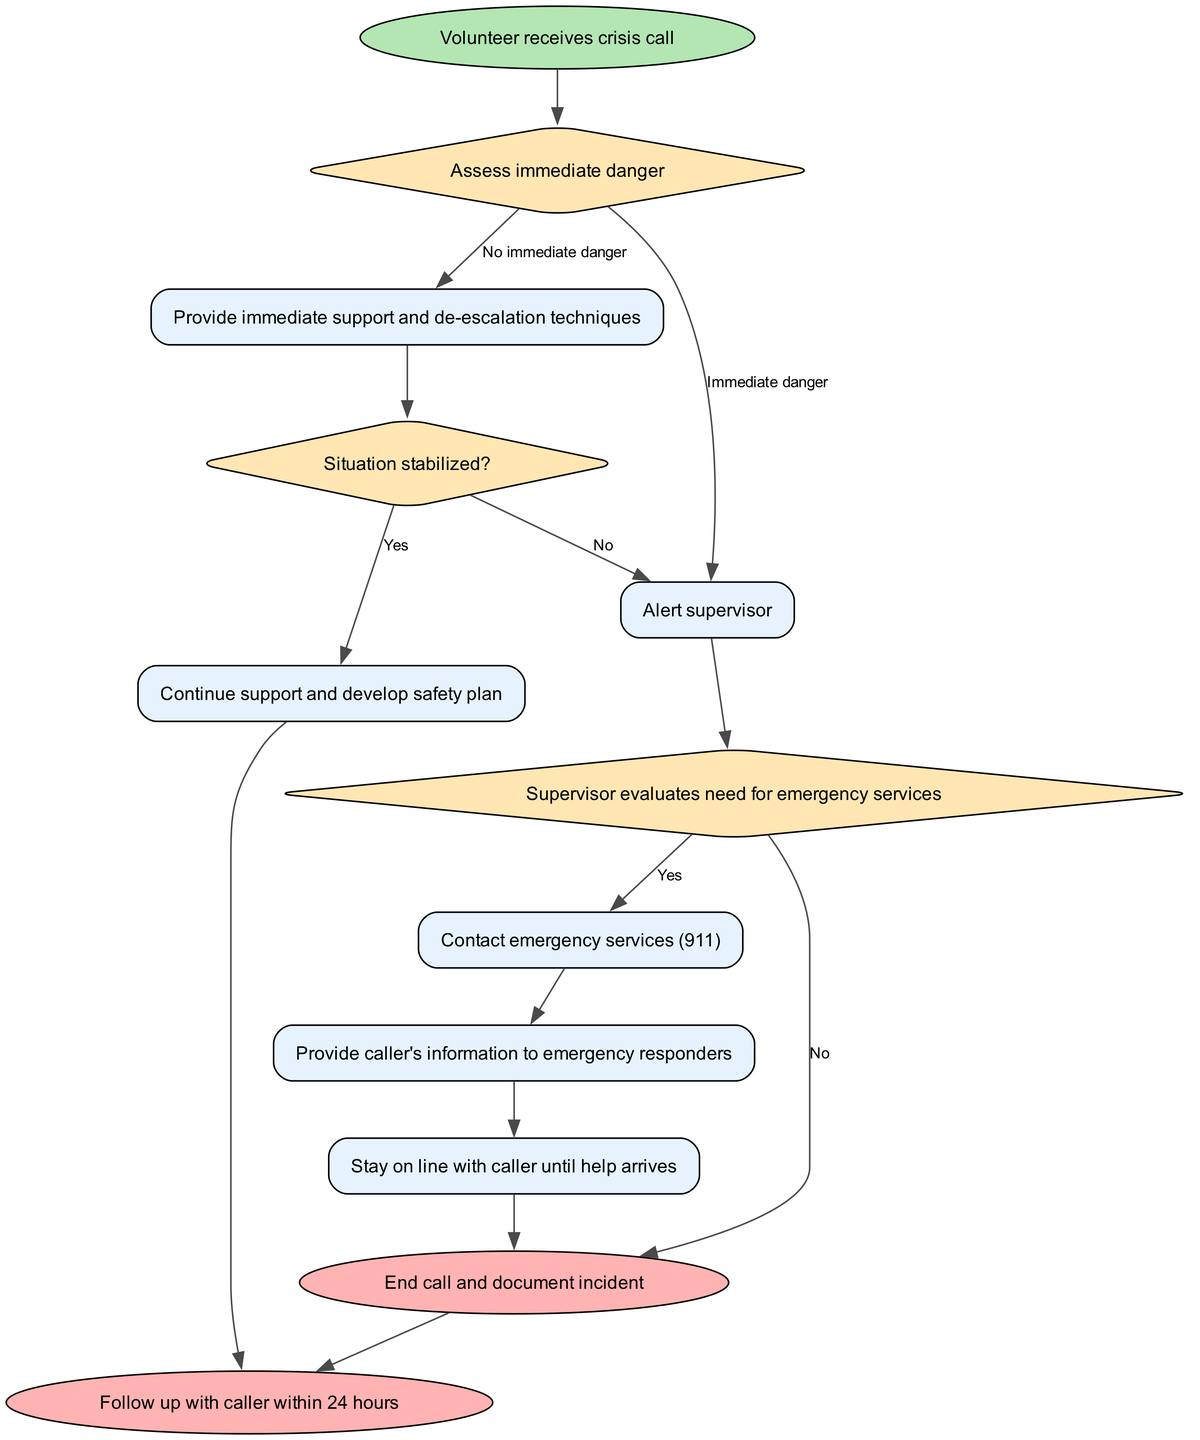What is the first action taken after receiving a crisis call? The first action taken is represented by the node labeled "Provide immediate support and de-escalation techniques," which occurs after the assessment of immediate danger.
Answer: Provide immediate support and de-escalation techniques How many decision nodes are in the diagram? The diagram contains three decision nodes, which are used to evaluate the situation at various points in the process.
Answer: 3 What happens if the supervisor evaluates the need for emergency services and decides there is no need? If the supervisor evaluates the situation and decides there is no need for emergency services, the flow goes to the "End call and document incident," which signifies a completion of the call without involving emergency services.
Answer: End call and document incident What is the final action taken in this crisis escalation process? The final action taken in the process is represented by the node labeled "Follow up with caller within 24 hours," which occurs after the call is ended and documented.
Answer: Follow up with caller within 24 hours What action occurs if the situation is stabilized? If the situation is stabilized, the action taken is to "Continue support and develop safety plan," which indicates ongoing support for the caller.
Answer: Continue support and develop safety plan What is the path taken if immediate danger is assessed? If immediate danger is assessed, the path leads to alerting the supervisor, who will then evaluate the need for emergency services as the next step in the process.
Answer: Alert supervisor 